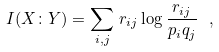Convert formula to latex. <formula><loc_0><loc_0><loc_500><loc_500>I ( X \colon Y ) = \sum _ { i , j } \, r _ { i j } \log \frac { r _ { i j } } { p _ { i } q _ { j } } \ ,</formula> 